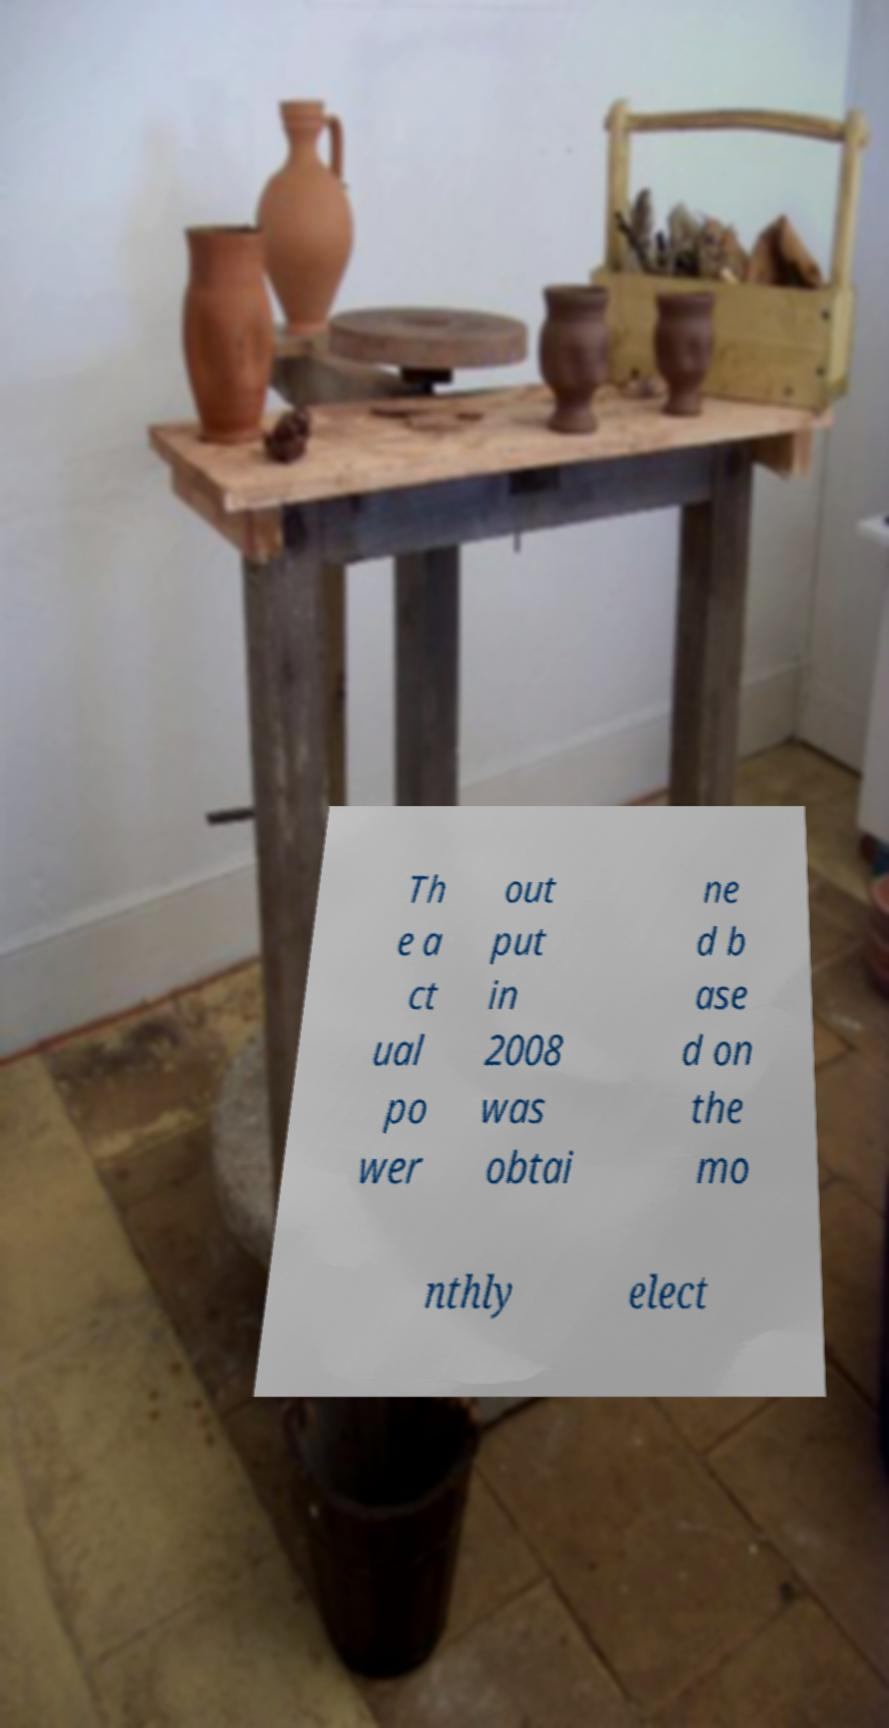For documentation purposes, I need the text within this image transcribed. Could you provide that? Th e a ct ual po wer out put in 2008 was obtai ne d b ase d on the mo nthly elect 